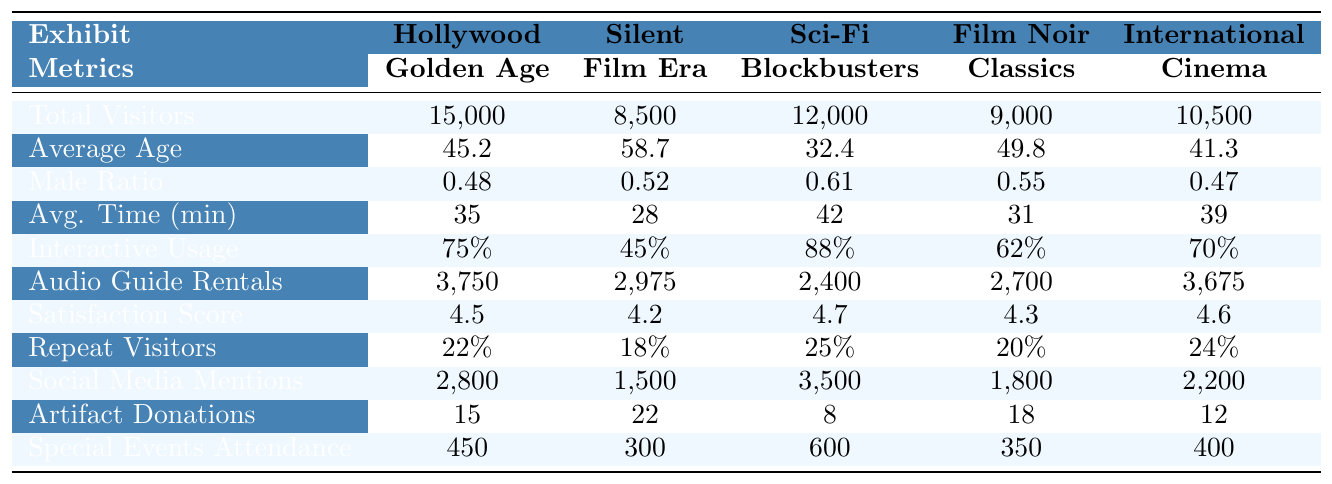What is the total number of visitors for the "Hollywood Golden Age" exhibit? The "Hollywood Golden Age" exhibit has 15,000 total visitors, as indicated in the table.
Answer: 15,000 Which exhibit had the highest average age of visitors? The "Silent Film Era" exhibit has the highest average age of 58.7 years, as stated in the average age row.
Answer: Silent Film Era What percentage of repeat visitors did the "Sci-Fi Blockbusters" exhibit attract? The "Sci-Fi Blockbusters" exhibit attracted 25% repeat visitors, which is noted in the repeat visitors percentage row.
Answer: 25% How many audio guide rentals were there for the "Film Noir Classics" exhibit? The "Film Noir Classics" exhibit had 2,700 audio guide rentals, according to the audio guide rentals row.
Answer: 2,700 What is the average time spent by visitors in the "International Cinema" exhibit? Visitors spent an average of 39 minutes in the "International Cinema" exhibit, as indicated in the table's average time spent row.
Answer: 39 Is the visitor satisfaction score higher for "Hollywood Golden Age" compared to "Film Noir Classics"? The "Hollywood Golden Age" exhibit has a satisfaction score of 4.5, while "Film Noir Classics" has a score of 4.3. Since 4.5 > 4.3, it is indeed higher.
Answer: Yes What is the difference in total visitors between the "Silent Film Era" and "Hollywood Golden Age"? The "Silent Film Era" had 8,500 visitors and the "Hollywood Golden Age" had 15,000. The difference is 15,000 - 8,500 = 6,500.
Answer: 6,500 Which exhibit had the least amount of social media mentions? The "Silent Film Era" exhibit had the least amount of social media mentions with 1,500, as shown in the social media mentions row.
Answer: Silent Film Era Calculate the average number of artifact donations received across all exhibits. To find the average, sum the donations (15 + 22 + 8 + 18 + 12 = 75) and divide by the number of exhibits (75/5 = 15).
Answer: 15 Which exhibit had the highest usage of interactive elements? The "Sci-Fi Blockbusters" exhibit had the highest usage of interactive elements at 88%, as indicated in the interactive elements usage row.
Answer: Sci-Fi Blockbusters What is the total attendance for special events across all exhibits? Summing the special events attendance for each exhibit: 450 + 300 + 600 + 350 + 400 = 2100.
Answer: 2100 Was the visitor satisfaction score for "International Cinema" higher than that for "Silent Film Era"? The visitor satisfaction score for "International Cinema" is 4.6 and for "Silent Film Era" it is 4.2. Since 4.6 > 4.2, it is higher.
Answer: Yes How many more social media mentions did "Sci-Fi Blockbusters" receive compared to "Film Noir Classics"? "Sci-Fi Blockbusters" received 3,500 mentions while "Film Noir Classics" received 1,800. The difference is 3,500 - 1,800 = 1,700.
Answer: 1,700 What is the average gender ratio of male visitors across all exhibits? Using the male ratios: (0.48 + 0.52 + 0.61 + 0.55 + 0.47) / 5 = 0.524.
Answer: 0.524 Which exhibit had the lowest percentage of repeat visitors? The "Silent Film Era" had the lowest percentage of repeat visitors at 18%, according to the repeat visitors percentage row.
Answer: Silent Film Era 